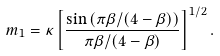<formula> <loc_0><loc_0><loc_500><loc_500>m _ { 1 } = \kappa \left [ \frac { \sin \left ( \pi \beta / ( 4 - \beta ) \right ) } { \pi \beta / ( 4 - \beta ) } \right ] ^ { 1 / 2 } .</formula> 